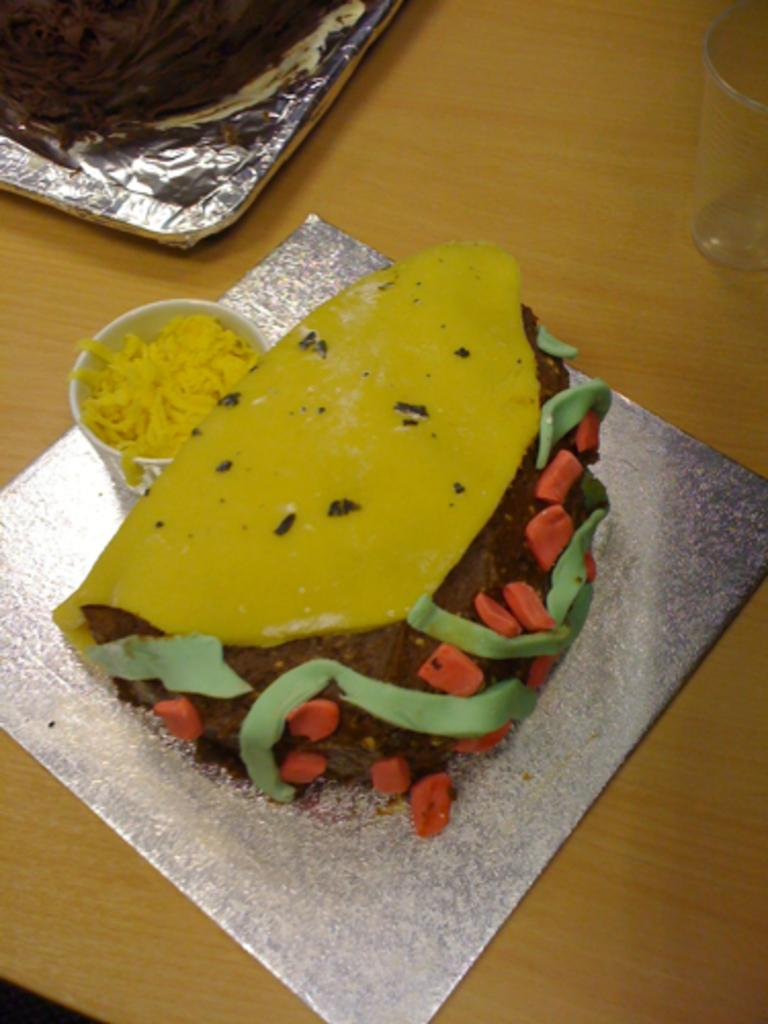What is placed on the wooden platform in the image? There is a cake, a glass, and a bowl with food on the wooden platform. Can you describe the contents of the bowl on the wooden platform? The bowl contains food, but the specific type of food is not discernible from the image. What other objects are present on the wooden platform? There is a glass on the wooden platform. What type of farm animals can be seen grazing near the cake on the wooden platform? There are no farm animals present in the image; it only features a cake, a glass, and a bowl with food on a wooden platform. What color are the lips of the person holding the cake in the image? There is no person holding the cake in the image, and therefore no lips to describe. 